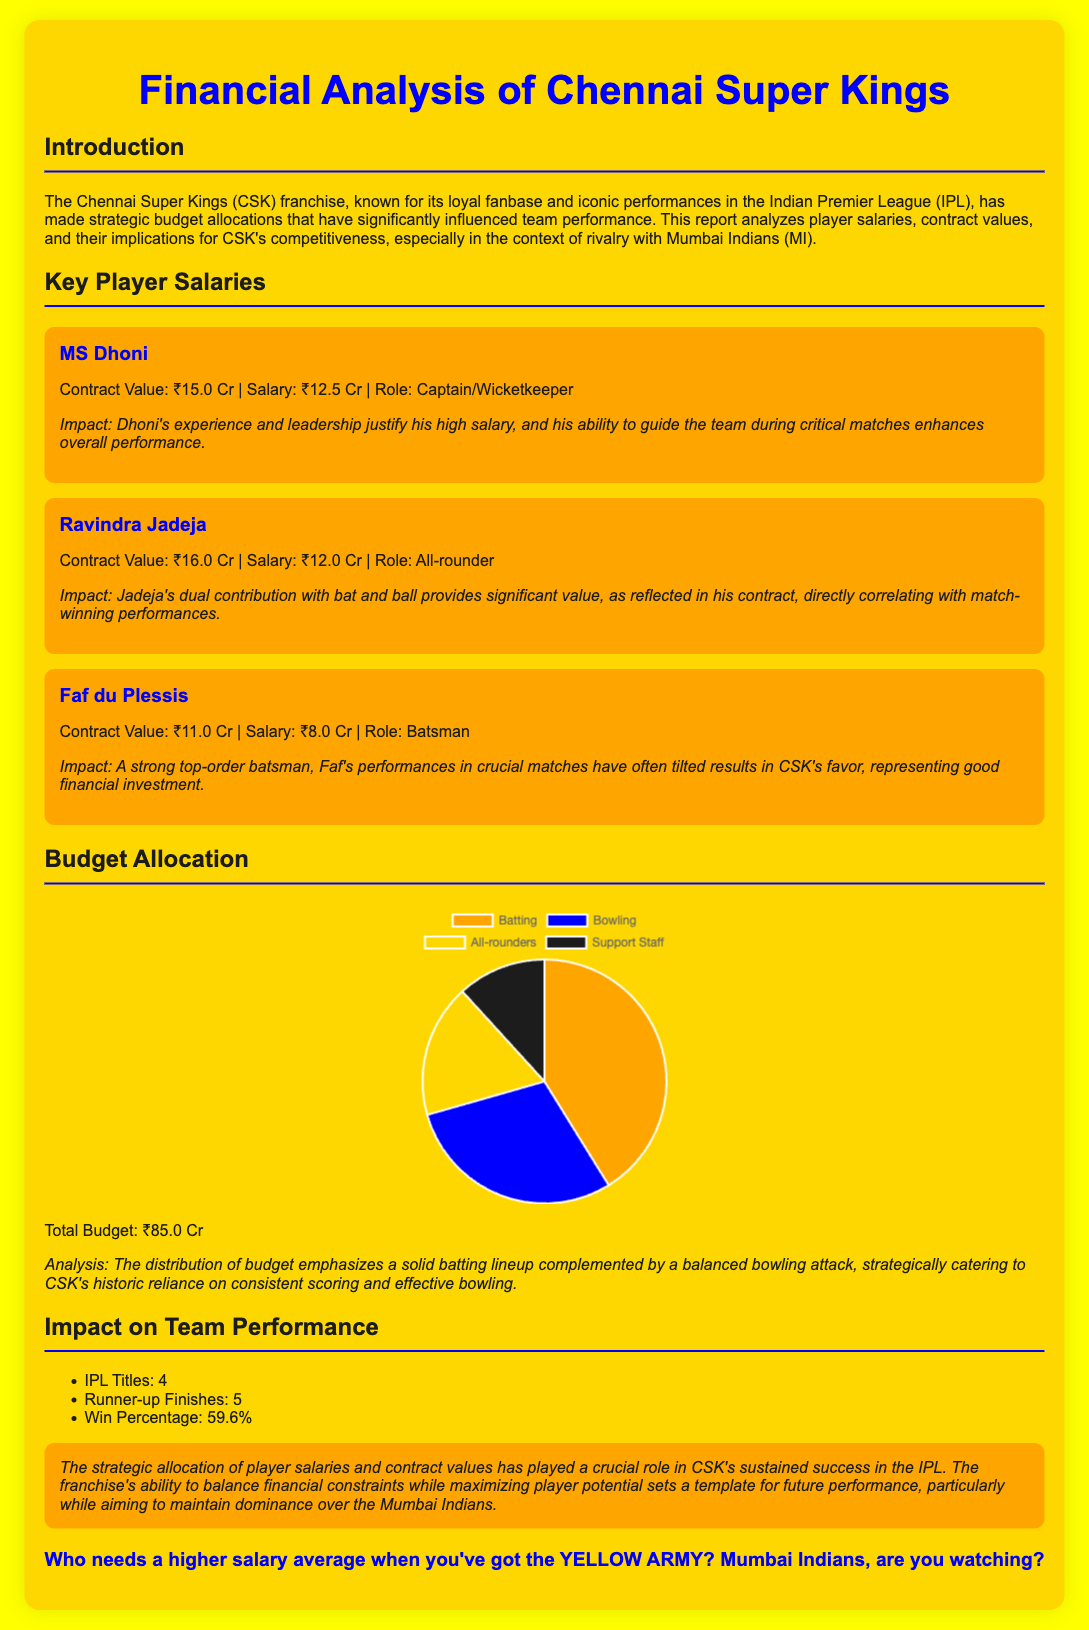What is MS Dhoni's salary? The document states that MS Dhoni's salary is ₹12.5 Cr.
Answer: ₹12.5 Cr What is the contract value of Ravindra Jadeja? According to the document, Ravindra Jadeja's contract value is ₹16.0 Cr.
Answer: ₹16.0 Cr How many IPL titles has CSK won? The report mentions that CSK has won 4 IPL titles.
Answer: 4 What is the total budget for CSK? The document specifies that the total budget is ₹85.0 Cr.
Answer: ₹85.0 Cr What percentage is allocated to batting in the budget? The budget allocation indicates that 35% is allocated to batting.
Answer: 35% What role does Faf du Plessis play in the team? The document states that Faf du Plessis is a batsman.
Answer: Batsman What is the win percentage of CSK? The report states that CSK's win percentage is 59.6%.
Answer: 59.6% What color represents the budget for bowling? The document shows that the budget for bowling is represented in blue.
Answer: Blue How many runner-up finishes does CSK have? The report states that CSK has 5 runner-up finishes in the IPL.
Answer: 5 